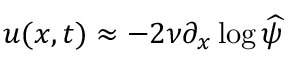<formula> <loc_0><loc_0><loc_500><loc_500>u ( x , t ) \approx - 2 \nu \partial _ { x } \log \widehat { \psi }</formula> 